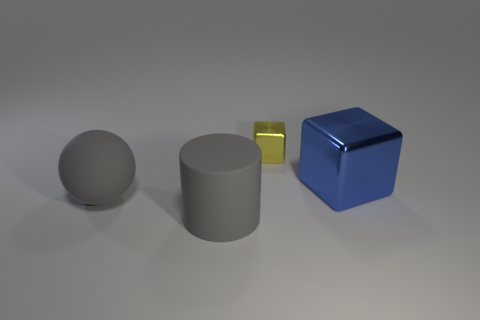Are there any other things that are the same size as the yellow metallic block?
Provide a short and direct response. No. Are there any big brown objects?
Your response must be concise. No. Is there a cylinder that has the same material as the gray ball?
Provide a short and direct response. Yes. There is a blue cube that is the same size as the gray matte ball; what material is it?
Your answer should be very brief. Metal. How many other things are the same shape as the yellow shiny thing?
Your answer should be compact. 1. What is the size of the gray object that is made of the same material as the large ball?
Offer a terse response. Large. The thing that is both on the left side of the blue shiny block and behind the large rubber ball is made of what material?
Make the answer very short. Metal. How many other metal objects have the same size as the yellow object?
Your answer should be very brief. 0. What is the material of the yellow object that is the same shape as the big blue metallic thing?
Keep it short and to the point. Metal. How many things are either things that are to the left of the big shiny cube or large things that are to the left of the large matte cylinder?
Ensure brevity in your answer.  3. 